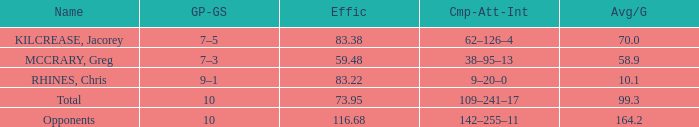What is the average per game (avg/g) of chris rhines with an efficiency (effic) higher than 73.95? 10.1. Parse the table in full. {'header': ['Name', 'GP-GS', 'Effic', 'Cmp-Att-Int', 'Avg/G'], 'rows': [['KILCREASE, Jacorey', '7–5', '83.38', '62–126–4', '70.0'], ['MCCRARY, Greg', '7–3', '59.48', '38–95–13', '58.9'], ['RHINES, Chris', '9–1', '83.22', '9–20–0', '10.1'], ['Total', '10', '73.95', '109–241–17', '99.3'], ['Opponents', '10', '116.68', '142–255–11', '164.2']]} 